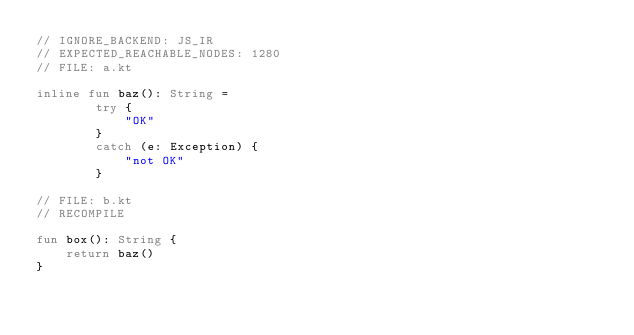Convert code to text. <code><loc_0><loc_0><loc_500><loc_500><_Kotlin_>// IGNORE_BACKEND: JS_IR
// EXPECTED_REACHABLE_NODES: 1280
// FILE: a.kt

inline fun baz(): String =
        try {
            "OK"
        }
        catch (e: Exception) {
            "not OK"
        }

// FILE: b.kt
// RECOMPILE

fun box(): String {
    return baz()
}</code> 